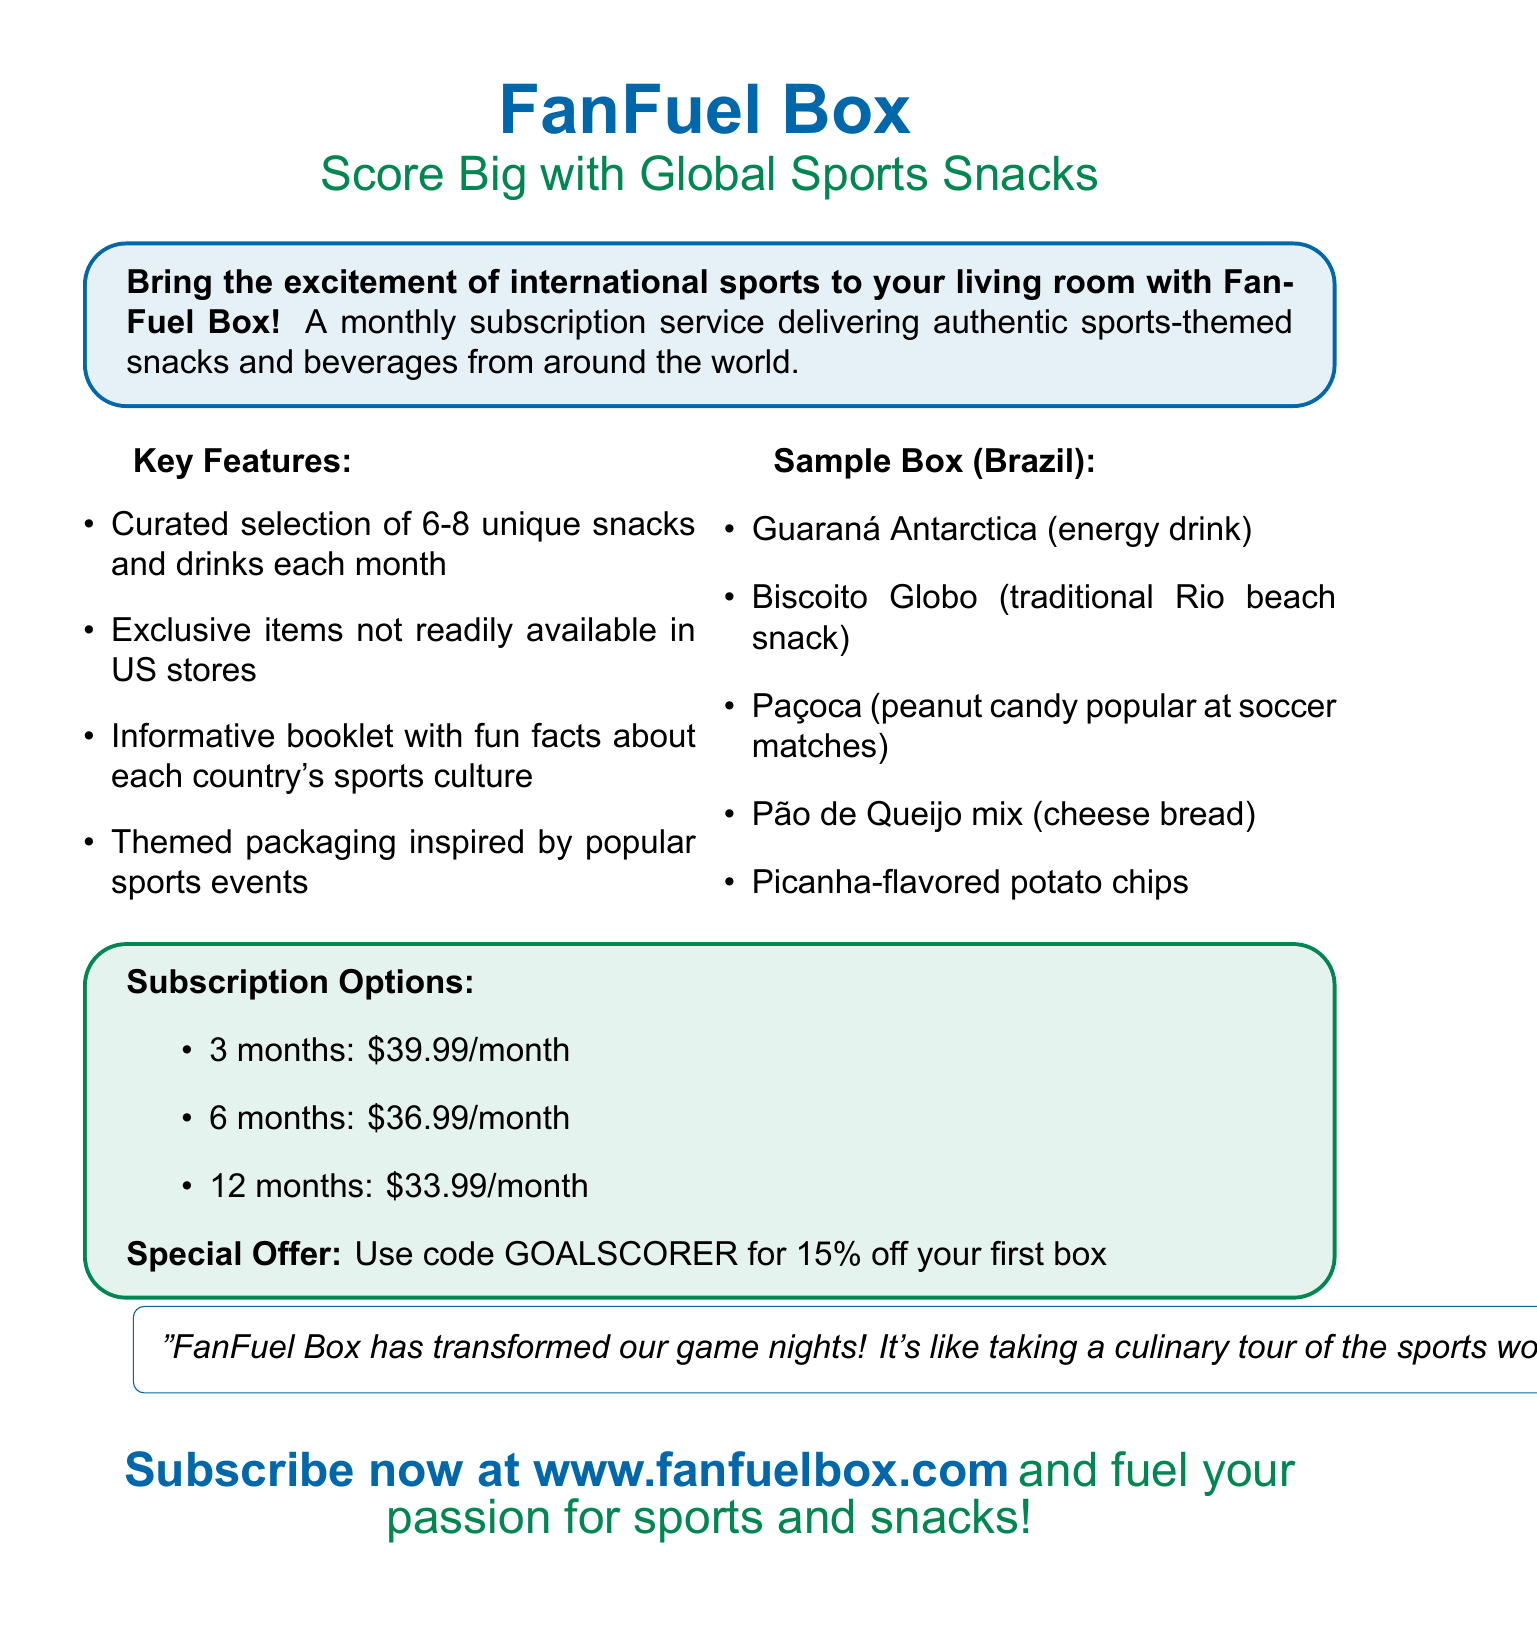What is the name of the subscription service? The subscription service is called FanFuel Box.
Answer: FanFuel Box How many snacks and drinks are curated each month? The document states that 6-8 unique snacks and drinks are included each month.
Answer: 6-8 What is one of the exclusive items mentioned? An exclusive item mentioned is Guaraná Antarctica.
Answer: Guaraná Antarctica What country is featured in the sample box? The sample box features items from Brazil.
Answer: Brazil What is the discount code for the first box? The special offer code for the first box is GOALSCORER.
Answer: GOALSCORER How much does a 12-month subscription cost per month? The cost per month for a 12-month subscription is $33.99.
Answer: $33.99 What type of cultural information is included in the box? The box includes an informative booklet with fun facts about each country's sports culture.
Answer: Fun facts about sports culture Who provided a testimonial about the service? The testimonial was provided by Mike Johnson.
Answer: Mike Johnson How should interested customers subscribe? Customers can subscribe by visiting the website www.fanfuelbox.com.
Answer: www.fanfuelbox.com 